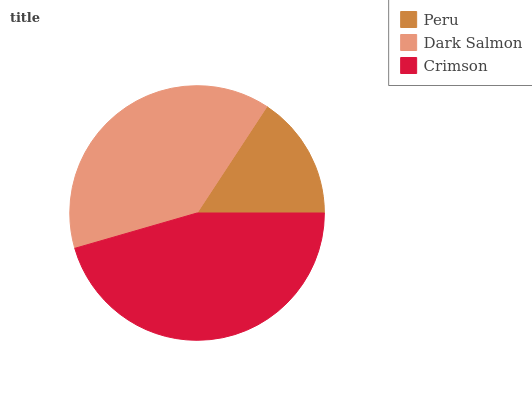Is Peru the minimum?
Answer yes or no. Yes. Is Crimson the maximum?
Answer yes or no. Yes. Is Dark Salmon the minimum?
Answer yes or no. No. Is Dark Salmon the maximum?
Answer yes or no. No. Is Dark Salmon greater than Peru?
Answer yes or no. Yes. Is Peru less than Dark Salmon?
Answer yes or no. Yes. Is Peru greater than Dark Salmon?
Answer yes or no. No. Is Dark Salmon less than Peru?
Answer yes or no. No. Is Dark Salmon the high median?
Answer yes or no. Yes. Is Dark Salmon the low median?
Answer yes or no. Yes. Is Peru the high median?
Answer yes or no. No. Is Peru the low median?
Answer yes or no. No. 